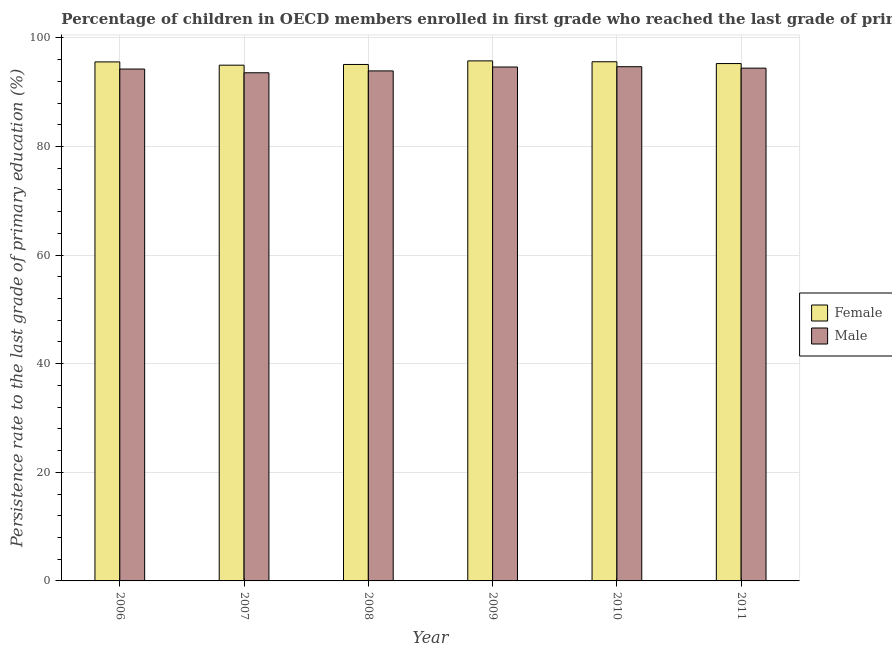What is the persistence rate of male students in 2009?
Ensure brevity in your answer.  94.64. Across all years, what is the maximum persistence rate of female students?
Provide a succinct answer. 95.77. Across all years, what is the minimum persistence rate of female students?
Make the answer very short. 94.98. What is the total persistence rate of male students in the graph?
Offer a very short reply. 565.53. What is the difference between the persistence rate of female students in 2007 and that in 2008?
Make the answer very short. -0.13. What is the difference between the persistence rate of female students in 2009 and the persistence rate of male students in 2010?
Provide a short and direct response. 0.16. What is the average persistence rate of male students per year?
Provide a short and direct response. 94.26. In how many years, is the persistence rate of male students greater than 80 %?
Ensure brevity in your answer.  6. What is the ratio of the persistence rate of male students in 2006 to that in 2011?
Offer a terse response. 1. Is the difference between the persistence rate of male students in 2006 and 2007 greater than the difference between the persistence rate of female students in 2006 and 2007?
Keep it short and to the point. No. What is the difference between the highest and the second highest persistence rate of male students?
Provide a short and direct response. 0.05. What is the difference between the highest and the lowest persistence rate of female students?
Ensure brevity in your answer.  0.79. How many bars are there?
Keep it short and to the point. 12. What is the difference between two consecutive major ticks on the Y-axis?
Give a very brief answer. 20. Are the values on the major ticks of Y-axis written in scientific E-notation?
Make the answer very short. No. Does the graph contain any zero values?
Your answer should be very brief. No. Does the graph contain grids?
Your answer should be very brief. Yes. Where does the legend appear in the graph?
Ensure brevity in your answer.  Center right. How many legend labels are there?
Ensure brevity in your answer.  2. What is the title of the graph?
Ensure brevity in your answer.  Percentage of children in OECD members enrolled in first grade who reached the last grade of primary education. What is the label or title of the Y-axis?
Make the answer very short. Persistence rate to the last grade of primary education (%). What is the Persistence rate to the last grade of primary education (%) in Female in 2006?
Your answer should be very brief. 95.58. What is the Persistence rate to the last grade of primary education (%) in Male in 2006?
Offer a very short reply. 94.27. What is the Persistence rate to the last grade of primary education (%) of Female in 2007?
Offer a terse response. 94.98. What is the Persistence rate to the last grade of primary education (%) of Male in 2007?
Offer a terse response. 93.58. What is the Persistence rate to the last grade of primary education (%) in Female in 2008?
Your answer should be very brief. 95.11. What is the Persistence rate to the last grade of primary education (%) of Male in 2008?
Make the answer very short. 93.92. What is the Persistence rate to the last grade of primary education (%) of Female in 2009?
Your answer should be compact. 95.77. What is the Persistence rate to the last grade of primary education (%) in Male in 2009?
Make the answer very short. 94.64. What is the Persistence rate to the last grade of primary education (%) of Female in 2010?
Keep it short and to the point. 95.61. What is the Persistence rate to the last grade of primary education (%) in Male in 2010?
Provide a short and direct response. 94.69. What is the Persistence rate to the last grade of primary education (%) of Female in 2011?
Ensure brevity in your answer.  95.28. What is the Persistence rate to the last grade of primary education (%) in Male in 2011?
Provide a short and direct response. 94.43. Across all years, what is the maximum Persistence rate to the last grade of primary education (%) of Female?
Your answer should be very brief. 95.77. Across all years, what is the maximum Persistence rate to the last grade of primary education (%) in Male?
Your answer should be compact. 94.69. Across all years, what is the minimum Persistence rate to the last grade of primary education (%) of Female?
Keep it short and to the point. 94.98. Across all years, what is the minimum Persistence rate to the last grade of primary education (%) of Male?
Offer a terse response. 93.58. What is the total Persistence rate to the last grade of primary education (%) of Female in the graph?
Make the answer very short. 572.32. What is the total Persistence rate to the last grade of primary education (%) of Male in the graph?
Your answer should be very brief. 565.53. What is the difference between the Persistence rate to the last grade of primary education (%) of Female in 2006 and that in 2007?
Ensure brevity in your answer.  0.6. What is the difference between the Persistence rate to the last grade of primary education (%) of Male in 2006 and that in 2007?
Keep it short and to the point. 0.69. What is the difference between the Persistence rate to the last grade of primary education (%) of Female in 2006 and that in 2008?
Provide a succinct answer. 0.47. What is the difference between the Persistence rate to the last grade of primary education (%) in Male in 2006 and that in 2008?
Ensure brevity in your answer.  0.34. What is the difference between the Persistence rate to the last grade of primary education (%) of Female in 2006 and that in 2009?
Offer a terse response. -0.19. What is the difference between the Persistence rate to the last grade of primary education (%) of Male in 2006 and that in 2009?
Your answer should be very brief. -0.37. What is the difference between the Persistence rate to the last grade of primary education (%) of Female in 2006 and that in 2010?
Your answer should be compact. -0.03. What is the difference between the Persistence rate to the last grade of primary education (%) of Male in 2006 and that in 2010?
Give a very brief answer. -0.43. What is the difference between the Persistence rate to the last grade of primary education (%) in Female in 2006 and that in 2011?
Ensure brevity in your answer.  0.3. What is the difference between the Persistence rate to the last grade of primary education (%) of Male in 2006 and that in 2011?
Provide a short and direct response. -0.16. What is the difference between the Persistence rate to the last grade of primary education (%) of Female in 2007 and that in 2008?
Your answer should be compact. -0.13. What is the difference between the Persistence rate to the last grade of primary education (%) in Male in 2007 and that in 2008?
Make the answer very short. -0.34. What is the difference between the Persistence rate to the last grade of primary education (%) of Female in 2007 and that in 2009?
Provide a short and direct response. -0.79. What is the difference between the Persistence rate to the last grade of primary education (%) of Male in 2007 and that in 2009?
Ensure brevity in your answer.  -1.06. What is the difference between the Persistence rate to the last grade of primary education (%) of Female in 2007 and that in 2010?
Offer a terse response. -0.63. What is the difference between the Persistence rate to the last grade of primary education (%) in Male in 2007 and that in 2010?
Provide a succinct answer. -1.12. What is the difference between the Persistence rate to the last grade of primary education (%) in Female in 2007 and that in 2011?
Ensure brevity in your answer.  -0.3. What is the difference between the Persistence rate to the last grade of primary education (%) of Male in 2007 and that in 2011?
Offer a very short reply. -0.85. What is the difference between the Persistence rate to the last grade of primary education (%) of Female in 2008 and that in 2009?
Provide a succinct answer. -0.66. What is the difference between the Persistence rate to the last grade of primary education (%) in Male in 2008 and that in 2009?
Keep it short and to the point. -0.72. What is the difference between the Persistence rate to the last grade of primary education (%) of Female in 2008 and that in 2010?
Provide a succinct answer. -0.5. What is the difference between the Persistence rate to the last grade of primary education (%) in Male in 2008 and that in 2010?
Give a very brief answer. -0.77. What is the difference between the Persistence rate to the last grade of primary education (%) of Female in 2008 and that in 2011?
Your answer should be very brief. -0.17. What is the difference between the Persistence rate to the last grade of primary education (%) of Male in 2008 and that in 2011?
Ensure brevity in your answer.  -0.51. What is the difference between the Persistence rate to the last grade of primary education (%) of Female in 2009 and that in 2010?
Offer a terse response. 0.16. What is the difference between the Persistence rate to the last grade of primary education (%) of Male in 2009 and that in 2010?
Offer a very short reply. -0.05. What is the difference between the Persistence rate to the last grade of primary education (%) of Female in 2009 and that in 2011?
Provide a short and direct response. 0.49. What is the difference between the Persistence rate to the last grade of primary education (%) in Male in 2009 and that in 2011?
Provide a succinct answer. 0.21. What is the difference between the Persistence rate to the last grade of primary education (%) of Female in 2010 and that in 2011?
Ensure brevity in your answer.  0.33. What is the difference between the Persistence rate to the last grade of primary education (%) of Male in 2010 and that in 2011?
Your response must be concise. 0.27. What is the difference between the Persistence rate to the last grade of primary education (%) of Female in 2006 and the Persistence rate to the last grade of primary education (%) of Male in 2007?
Ensure brevity in your answer.  2. What is the difference between the Persistence rate to the last grade of primary education (%) in Female in 2006 and the Persistence rate to the last grade of primary education (%) in Male in 2008?
Your answer should be compact. 1.66. What is the difference between the Persistence rate to the last grade of primary education (%) in Female in 2006 and the Persistence rate to the last grade of primary education (%) in Male in 2009?
Your answer should be very brief. 0.94. What is the difference between the Persistence rate to the last grade of primary education (%) in Female in 2006 and the Persistence rate to the last grade of primary education (%) in Male in 2010?
Give a very brief answer. 0.88. What is the difference between the Persistence rate to the last grade of primary education (%) in Female in 2006 and the Persistence rate to the last grade of primary education (%) in Male in 2011?
Provide a short and direct response. 1.15. What is the difference between the Persistence rate to the last grade of primary education (%) in Female in 2007 and the Persistence rate to the last grade of primary education (%) in Male in 2008?
Your answer should be very brief. 1.06. What is the difference between the Persistence rate to the last grade of primary education (%) of Female in 2007 and the Persistence rate to the last grade of primary education (%) of Male in 2009?
Your answer should be very brief. 0.34. What is the difference between the Persistence rate to the last grade of primary education (%) in Female in 2007 and the Persistence rate to the last grade of primary education (%) in Male in 2010?
Your answer should be very brief. 0.28. What is the difference between the Persistence rate to the last grade of primary education (%) of Female in 2007 and the Persistence rate to the last grade of primary education (%) of Male in 2011?
Offer a terse response. 0.55. What is the difference between the Persistence rate to the last grade of primary education (%) of Female in 2008 and the Persistence rate to the last grade of primary education (%) of Male in 2009?
Provide a short and direct response. 0.47. What is the difference between the Persistence rate to the last grade of primary education (%) of Female in 2008 and the Persistence rate to the last grade of primary education (%) of Male in 2010?
Your answer should be compact. 0.41. What is the difference between the Persistence rate to the last grade of primary education (%) in Female in 2008 and the Persistence rate to the last grade of primary education (%) in Male in 2011?
Provide a short and direct response. 0.68. What is the difference between the Persistence rate to the last grade of primary education (%) of Female in 2009 and the Persistence rate to the last grade of primary education (%) of Male in 2010?
Keep it short and to the point. 1.07. What is the difference between the Persistence rate to the last grade of primary education (%) in Female in 2009 and the Persistence rate to the last grade of primary education (%) in Male in 2011?
Make the answer very short. 1.34. What is the difference between the Persistence rate to the last grade of primary education (%) in Female in 2010 and the Persistence rate to the last grade of primary education (%) in Male in 2011?
Your answer should be very brief. 1.18. What is the average Persistence rate to the last grade of primary education (%) of Female per year?
Give a very brief answer. 95.39. What is the average Persistence rate to the last grade of primary education (%) in Male per year?
Your answer should be very brief. 94.26. In the year 2006, what is the difference between the Persistence rate to the last grade of primary education (%) in Female and Persistence rate to the last grade of primary education (%) in Male?
Offer a very short reply. 1.31. In the year 2007, what is the difference between the Persistence rate to the last grade of primary education (%) of Female and Persistence rate to the last grade of primary education (%) of Male?
Provide a short and direct response. 1.4. In the year 2008, what is the difference between the Persistence rate to the last grade of primary education (%) in Female and Persistence rate to the last grade of primary education (%) in Male?
Ensure brevity in your answer.  1.19. In the year 2009, what is the difference between the Persistence rate to the last grade of primary education (%) in Female and Persistence rate to the last grade of primary education (%) in Male?
Make the answer very short. 1.13. In the year 2010, what is the difference between the Persistence rate to the last grade of primary education (%) in Female and Persistence rate to the last grade of primary education (%) in Male?
Provide a succinct answer. 0.91. In the year 2011, what is the difference between the Persistence rate to the last grade of primary education (%) in Female and Persistence rate to the last grade of primary education (%) in Male?
Ensure brevity in your answer.  0.85. What is the ratio of the Persistence rate to the last grade of primary education (%) in Female in 2006 to that in 2007?
Give a very brief answer. 1.01. What is the ratio of the Persistence rate to the last grade of primary education (%) of Male in 2006 to that in 2007?
Make the answer very short. 1.01. What is the ratio of the Persistence rate to the last grade of primary education (%) in Female in 2006 to that in 2010?
Provide a succinct answer. 1. What is the ratio of the Persistence rate to the last grade of primary education (%) of Male in 2006 to that in 2010?
Ensure brevity in your answer.  1. What is the ratio of the Persistence rate to the last grade of primary education (%) in Female in 2007 to that in 2008?
Your response must be concise. 1. What is the ratio of the Persistence rate to the last grade of primary education (%) of Female in 2007 to that in 2009?
Keep it short and to the point. 0.99. What is the ratio of the Persistence rate to the last grade of primary education (%) of Female in 2007 to that in 2010?
Your answer should be compact. 0.99. What is the ratio of the Persistence rate to the last grade of primary education (%) in Male in 2007 to that in 2011?
Provide a succinct answer. 0.99. What is the ratio of the Persistence rate to the last grade of primary education (%) in Male in 2008 to that in 2009?
Provide a succinct answer. 0.99. What is the ratio of the Persistence rate to the last grade of primary education (%) of Female in 2008 to that in 2010?
Your response must be concise. 0.99. What is the ratio of the Persistence rate to the last grade of primary education (%) in Male in 2008 to that in 2010?
Provide a succinct answer. 0.99. What is the ratio of the Persistence rate to the last grade of primary education (%) of Female in 2009 to that in 2010?
Offer a very short reply. 1. What is the difference between the highest and the second highest Persistence rate to the last grade of primary education (%) of Female?
Provide a succinct answer. 0.16. What is the difference between the highest and the second highest Persistence rate to the last grade of primary education (%) in Male?
Provide a succinct answer. 0.05. What is the difference between the highest and the lowest Persistence rate to the last grade of primary education (%) in Female?
Offer a terse response. 0.79. What is the difference between the highest and the lowest Persistence rate to the last grade of primary education (%) of Male?
Give a very brief answer. 1.12. 